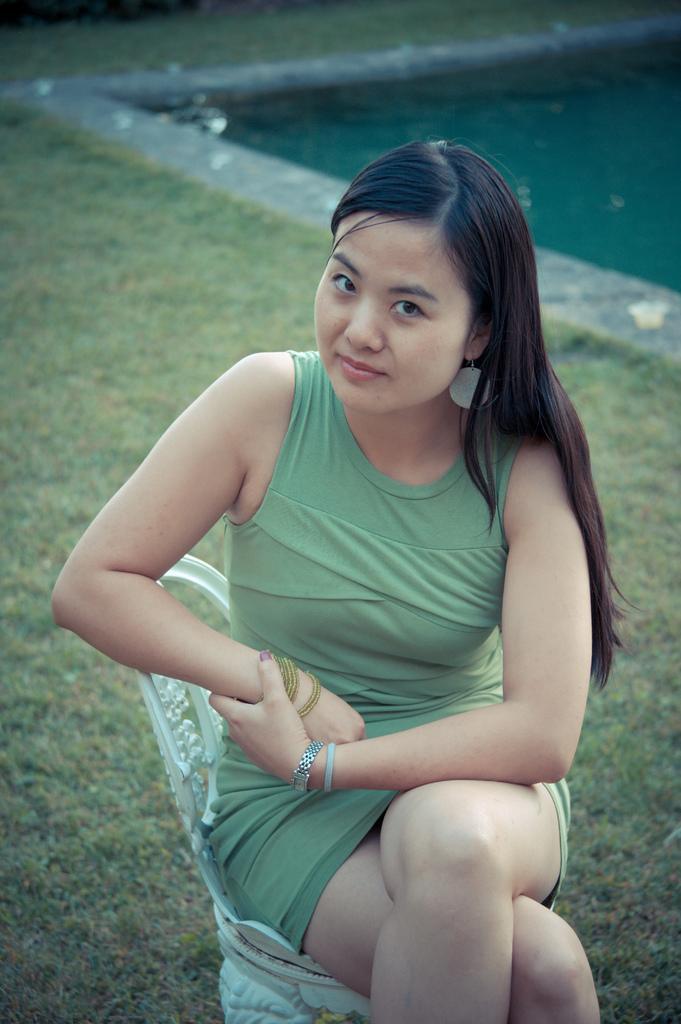Can you describe this image briefly? In the foreground of the picture there is a woman wearing a green dress and sitting in a child. In the foreground we can see grass also. On the right there is a swimming pool. At the top we can see greenery. 